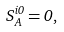Convert formula to latex. <formula><loc_0><loc_0><loc_500><loc_500>S _ { A } ^ { i 0 } = 0 ,</formula> 